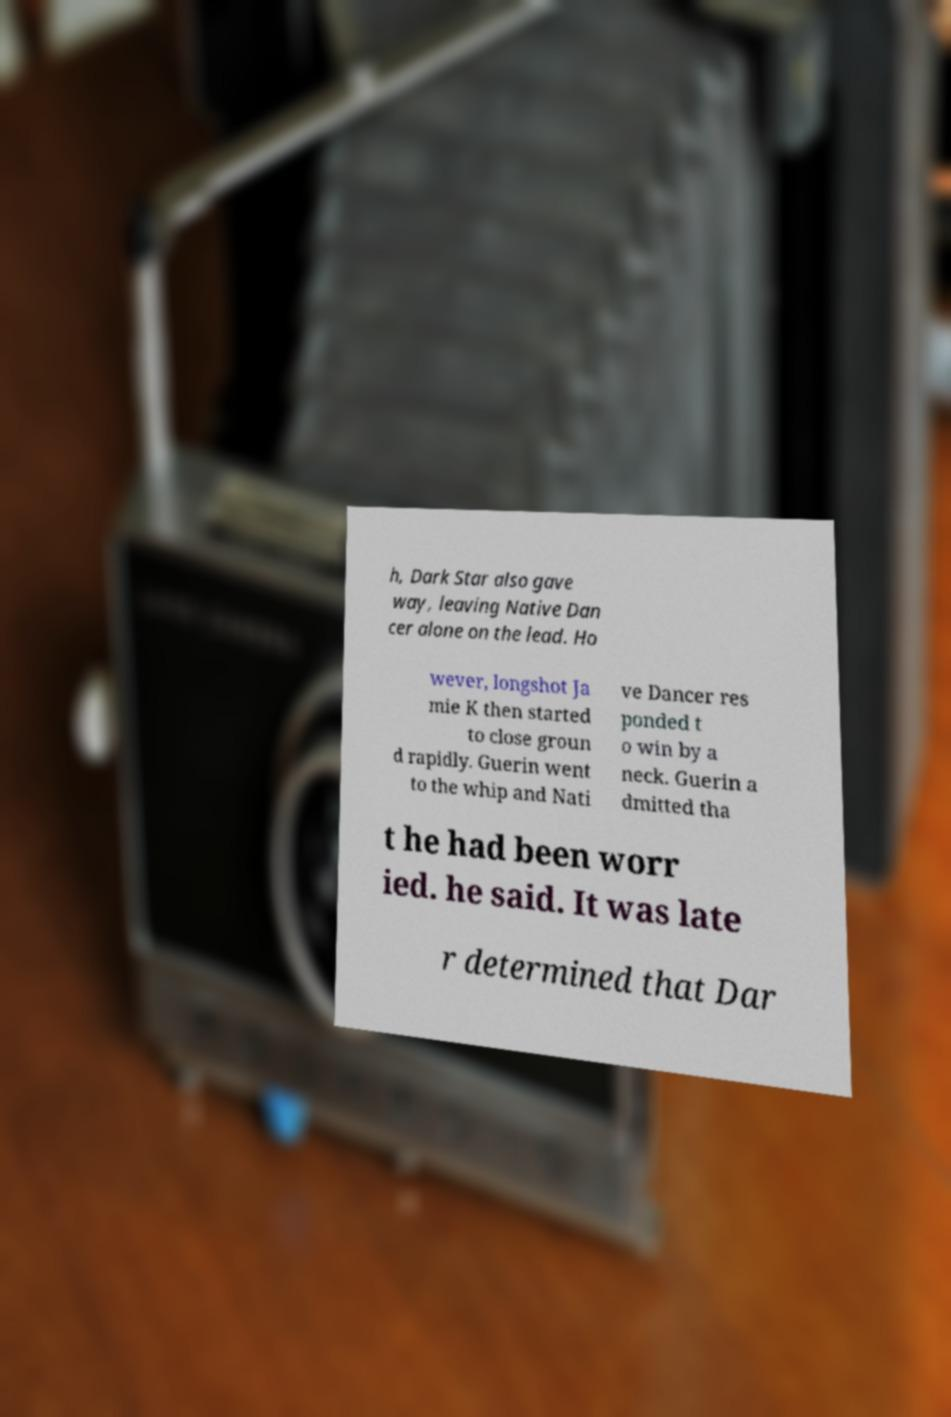For documentation purposes, I need the text within this image transcribed. Could you provide that? h, Dark Star also gave way, leaving Native Dan cer alone on the lead. Ho wever, longshot Ja mie K then started to close groun d rapidly. Guerin went to the whip and Nati ve Dancer res ponded t o win by a neck. Guerin a dmitted tha t he had been worr ied. he said. It was late r determined that Dar 